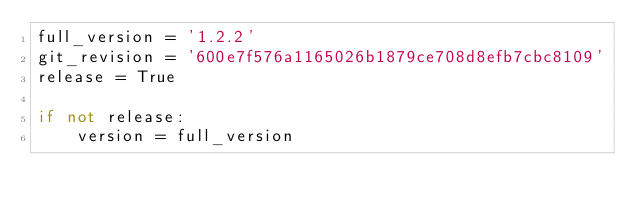Convert code to text. <code><loc_0><loc_0><loc_500><loc_500><_Python_>full_version = '1.2.2'
git_revision = '600e7f576a1165026b1879ce708d8efb7cbc8109'
release = True

if not release:
    version = full_version
</code> 